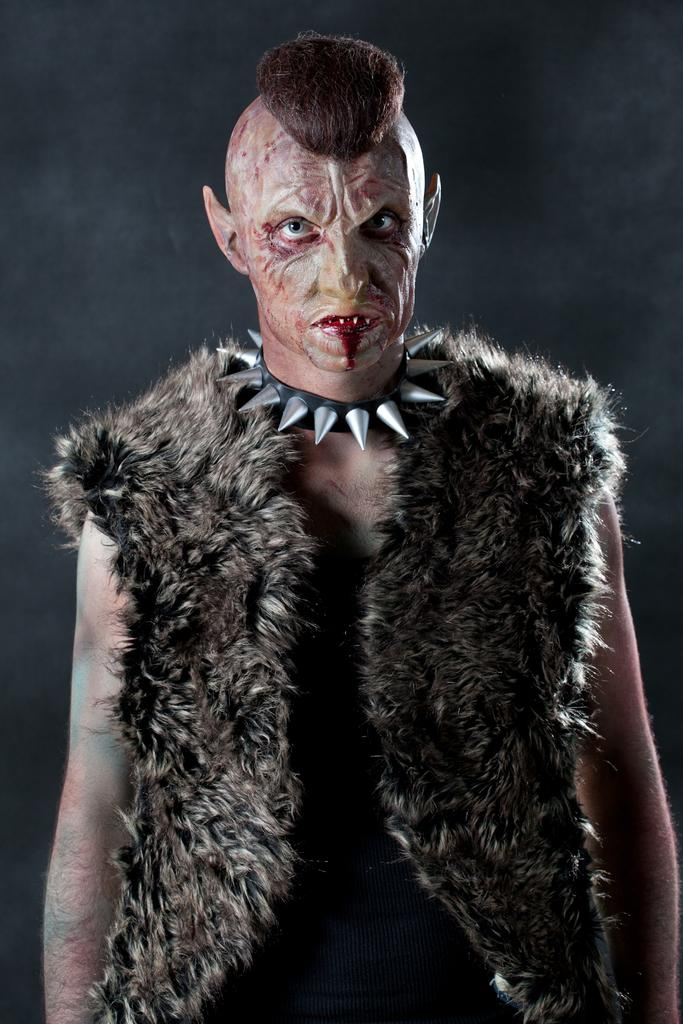What is the main subject of the image? There is a person in the image. What is the person wearing? The person is wearing a black dress. How would you describe the person's appearance? The person is stunning. What type of accessory can be seen around the person's neck? There is a chain around the person's neck. What color is the background of the image? The background of the image is black. What type of beef is being served at the insurance event in the image? There is no beef or insurance event present in the image; it features a person wearing a black dress with a chain around their neck and a black background. 